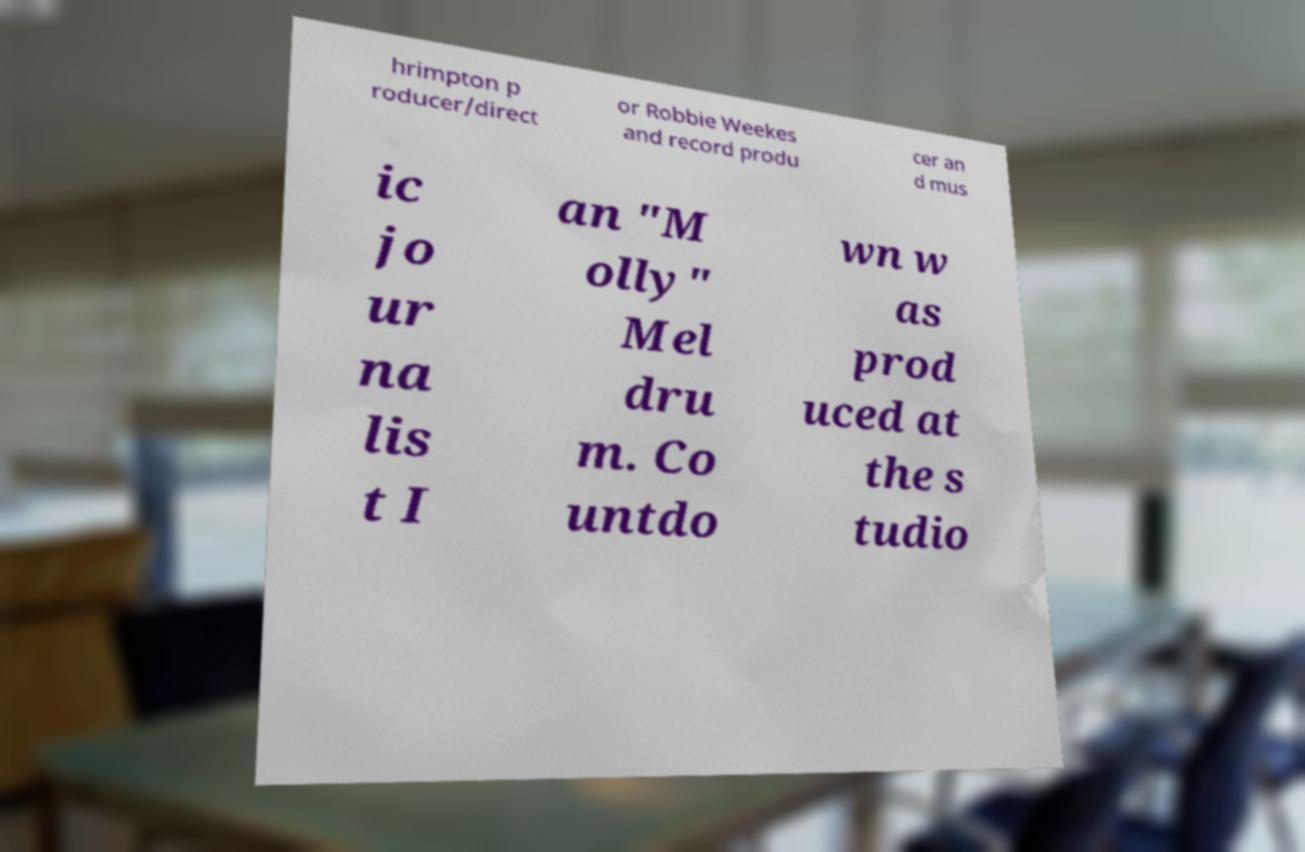Can you read and provide the text displayed in the image?This photo seems to have some interesting text. Can you extract and type it out for me? hrimpton p roducer/direct or Robbie Weekes and record produ cer an d mus ic jo ur na lis t I an "M olly" Mel dru m. Co untdo wn w as prod uced at the s tudio 